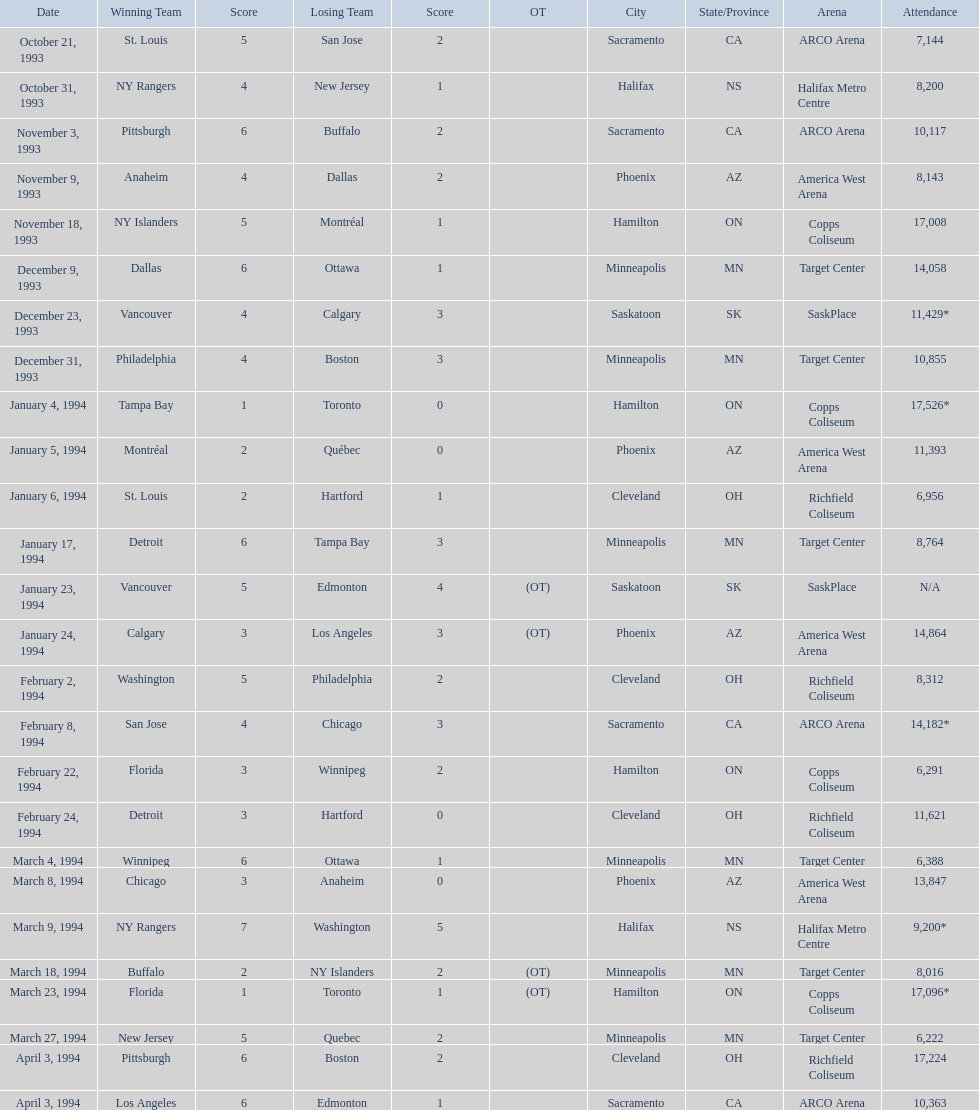What was the number of attendees on january 24, 1994? 14,864. Help me parse the entirety of this table. {'header': ['Date', 'Winning Team', 'Score', 'Losing Team', 'Score', 'OT', 'City', 'State/Province', 'Arena', 'Attendance'], 'rows': [['October 21, 1993', 'St. Louis', '5', 'San Jose', '2', '', 'Sacramento', 'CA', 'ARCO Arena', '7,144'], ['October 31, 1993', 'NY Rangers', '4', 'New Jersey', '1', '', 'Halifax', 'NS', 'Halifax Metro Centre', '8,200'], ['November 3, 1993', 'Pittsburgh', '6', 'Buffalo', '2', '', 'Sacramento', 'CA', 'ARCO Arena', '10,117'], ['November 9, 1993', 'Anaheim', '4', 'Dallas', '2', '', 'Phoenix', 'AZ', 'America West Arena', '8,143'], ['November 18, 1993', 'NY Islanders', '5', 'Montréal', '1', '', 'Hamilton', 'ON', 'Copps Coliseum', '17,008'], ['December 9, 1993', 'Dallas', '6', 'Ottawa', '1', '', 'Minneapolis', 'MN', 'Target Center', '14,058'], ['December 23, 1993', 'Vancouver', '4', 'Calgary', '3', '', 'Saskatoon', 'SK', 'SaskPlace', '11,429*'], ['December 31, 1993', 'Philadelphia', '4', 'Boston', '3', '', 'Minneapolis', 'MN', 'Target Center', '10,855'], ['January 4, 1994', 'Tampa Bay', '1', 'Toronto', '0', '', 'Hamilton', 'ON', 'Copps Coliseum', '17,526*'], ['January 5, 1994', 'Montréal', '2', 'Québec', '0', '', 'Phoenix', 'AZ', 'America West Arena', '11,393'], ['January 6, 1994', 'St. Louis', '2', 'Hartford', '1', '', 'Cleveland', 'OH', 'Richfield Coliseum', '6,956'], ['January 17, 1994', 'Detroit', '6', 'Tampa Bay', '3', '', 'Minneapolis', 'MN', 'Target Center', '8,764'], ['January 23, 1994', 'Vancouver', '5', 'Edmonton', '4', '(OT)', 'Saskatoon', 'SK', 'SaskPlace', 'N/A'], ['January 24, 1994', 'Calgary', '3', 'Los Angeles', '3', '(OT)', 'Phoenix', 'AZ', 'America West Arena', '14,864'], ['February 2, 1994', 'Washington', '5', 'Philadelphia', '2', '', 'Cleveland', 'OH', 'Richfield Coliseum', '8,312'], ['February 8, 1994', 'San Jose', '4', 'Chicago', '3', '', 'Sacramento', 'CA', 'ARCO Arena', '14,182*'], ['February 22, 1994', 'Florida', '3', 'Winnipeg', '2', '', 'Hamilton', 'ON', 'Copps Coliseum', '6,291'], ['February 24, 1994', 'Detroit', '3', 'Hartford', '0', '', 'Cleveland', 'OH', 'Richfield Coliseum', '11,621'], ['March 4, 1994', 'Winnipeg', '6', 'Ottawa', '1', '', 'Minneapolis', 'MN', 'Target Center', '6,388'], ['March 8, 1994', 'Chicago', '3', 'Anaheim', '0', '', 'Phoenix', 'AZ', 'America West Arena', '13,847'], ['March 9, 1994', 'NY Rangers', '7', 'Washington', '5', '', 'Halifax', 'NS', 'Halifax Metro Centre', '9,200*'], ['March 18, 1994', 'Buffalo', '2', 'NY Islanders', '2', '(OT)', 'Minneapolis', 'MN', 'Target Center', '8,016'], ['March 23, 1994', 'Florida', '1', 'Toronto', '1', '(OT)', 'Hamilton', 'ON', 'Copps Coliseum', '17,096*'], ['March 27, 1994', 'New Jersey', '5', 'Quebec', '2', '', 'Minneapolis', 'MN', 'Target Center', '6,222'], ['April 3, 1994', 'Pittsburgh', '6', 'Boston', '2', '', 'Cleveland', 'OH', 'Richfield Coliseum', '17,224'], ['April 3, 1994', 'Los Angeles', '6', 'Edmonton', '1', '', 'Sacramento', 'CA', 'ARCO Arena', '10,363']]} What was the number of attendees on december 23, 1993? 11,429*. Between january 24, 1994 and december 23, 1993, which had the higher number of attendees? January 4, 1994. When did the games take place? October 21, 1993, October 31, 1993, November 3, 1993, November 9, 1993, November 18, 1993, December 9, 1993, December 23, 1993, December 31, 1993, January 4, 1994, January 5, 1994, January 6, 1994, January 17, 1994, January 23, 1994, January 24, 1994, February 2, 1994, February 8, 1994, February 22, 1994, February 24, 1994, March 4, 1994, March 8, 1994, March 9, 1994, March 18, 1994, March 23, 1994, March 27, 1994, April 3, 1994, April 3, 1994. What was the number of spectators for each game? 7,144, 8,200, 10,117, 8,143, 17,008, 14,058, 11,429*, 10,855, 17,526*, 11,393, 6,956, 8,764, N/A, 14,864, 8,312, 14,182*, 6,291, 11,621, 6,388, 13,847, 9,200*, 8,016, 17,096*, 6,222, 17,224, 10,363. On which date was the highest attendance recorded? January 4, 1994. 